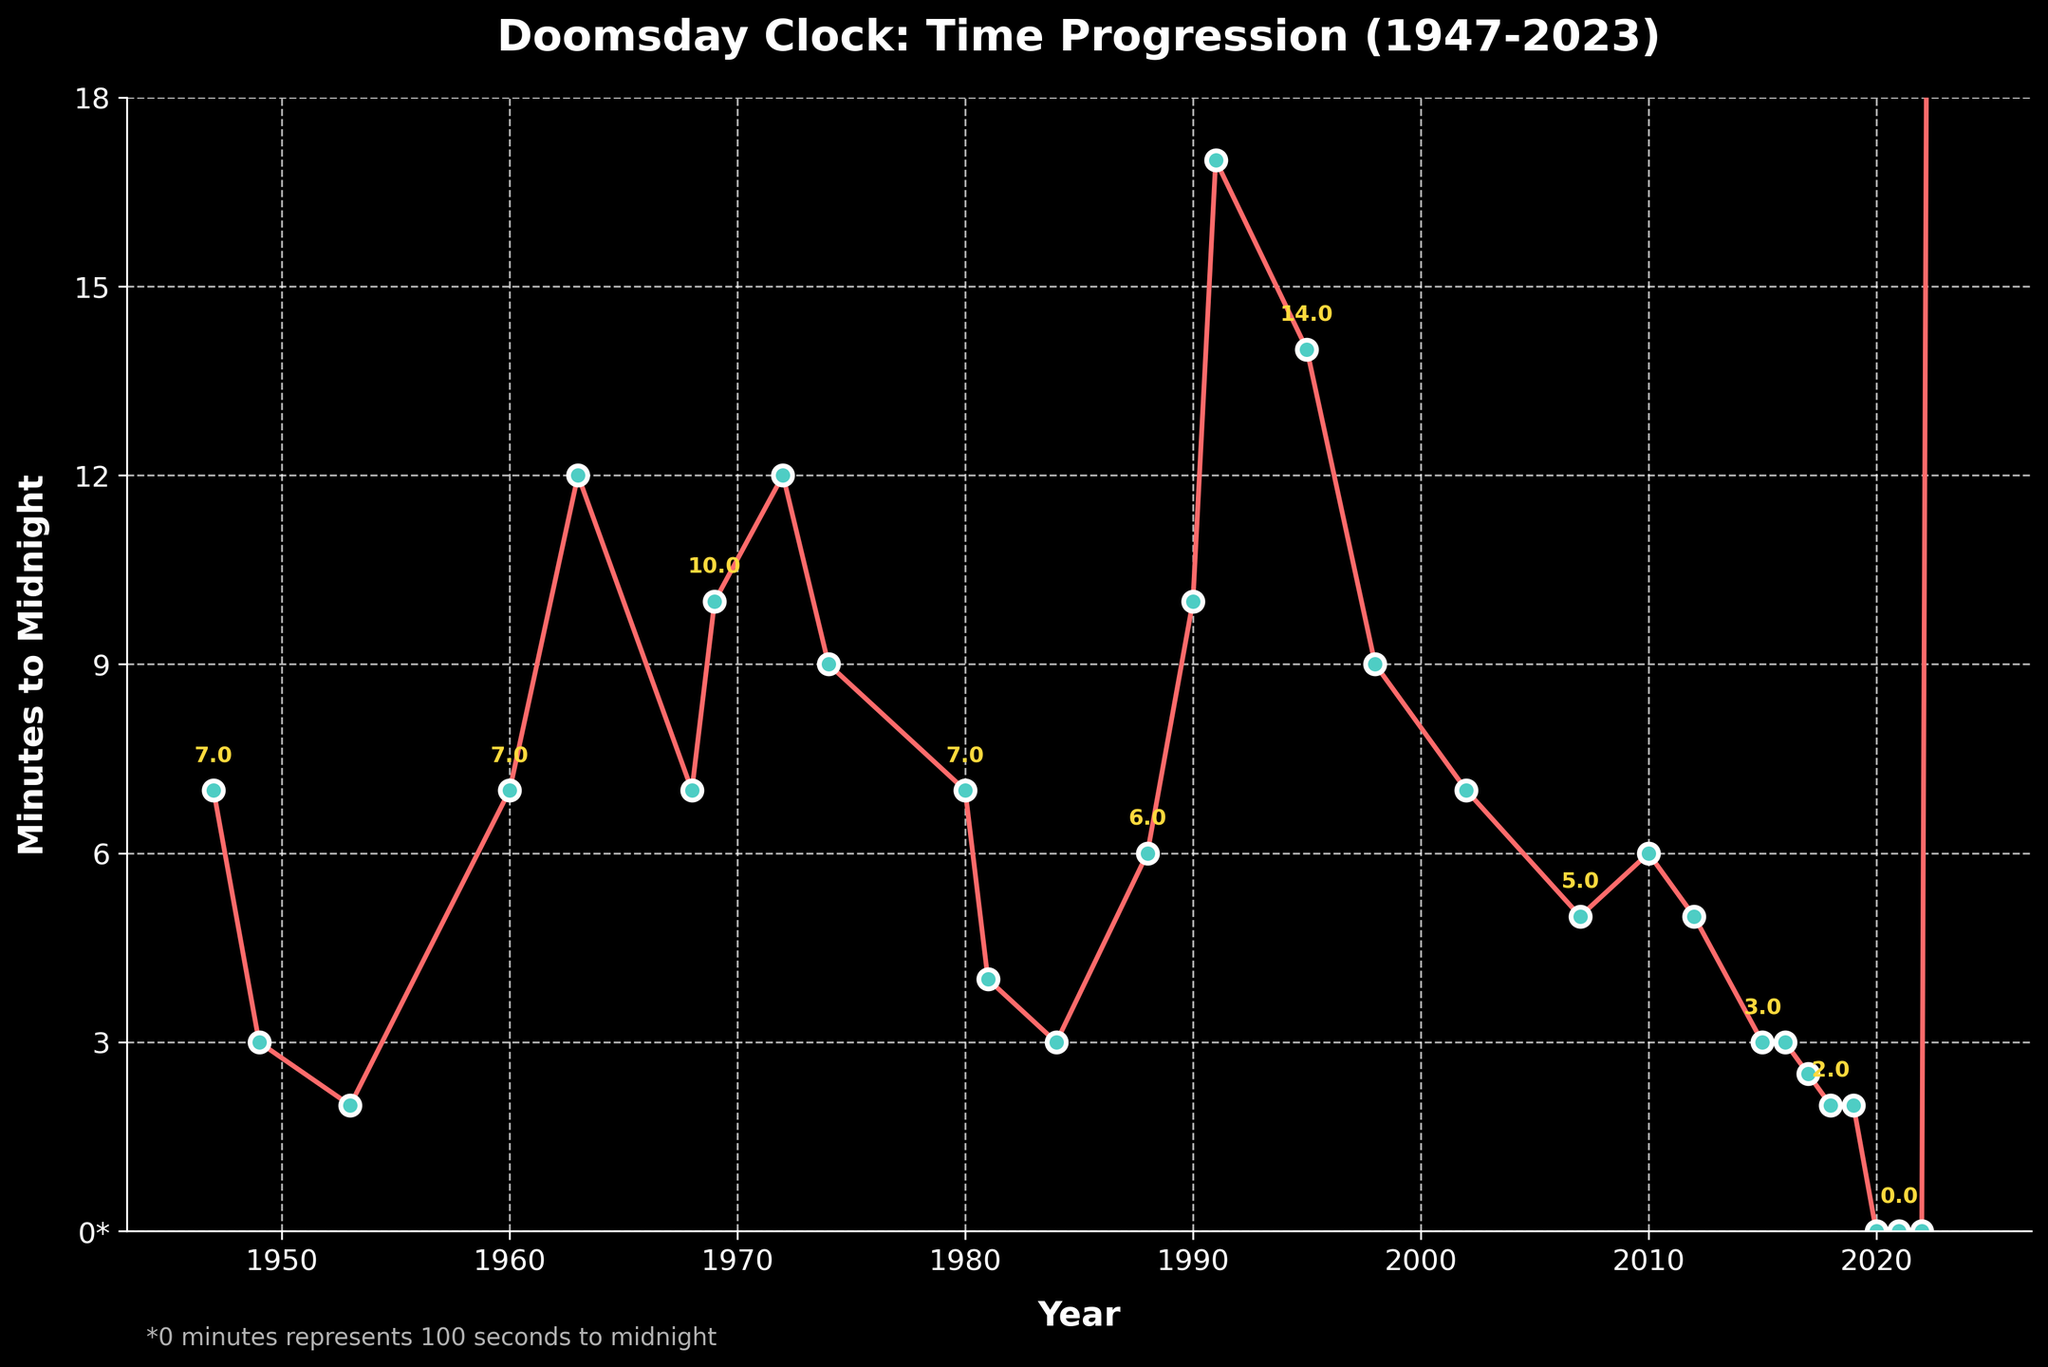What is the closest the Doomsday Clock has ever been to midnight? The closest time to midnight can be observed by identifying the smallest value on the y-axis. The smallest value shown is labeled as '2' and it occurs several times, such as in 1953 and 2018. This means the Doomsday Clock has been as close as 2 minutes to midnight.
Answer: 2 minutes How many times has the Doomsday Clock been set to exactly 7 minutes to midnight? By examining the y-axis values at intersections with the line chart, we identify the years where the y-value is 7. These years are 1947, 1960, 1980, and 2002. Therefore, the clock has been set to 7 minutes to midnight four times.
Answer: 4 times Which year experienced the largest increase in minutes to midnight in the period covered by the chart? To find the largest increase, we need to check the difference between consecutive data points. The largest jump is from 1991 (17) to 1995 (14), which is an increase of 3 minutes. Therefore, the largest increase appears visually to be in that period.
Answer: 1991 What's the longest period during which the Doomsday Clock stayed below 3 minutes to midnight? Identify periods where the value on the y-axis is consistently below 3. From 2017 to 2019, the values are 2.5, 2, and 2. Therefore, 2017 to 2019 is the longest period with the clock below 3 minutes.
Answer: 3 years In which year did the Doomsday Clock show the furthest time from midnight? The value furthest from midnight is the highest value on the y-axis. From the chart, the highest point is 17 minutes in 1991. This represents the furthest time from midnight.
Answer: 1991 What pattern do you observe in the movement of the Doomsday Clock between 1974 and 1991? Examining the chart, between 1974 and 1991, the Clock initially shows minutes above 7, reaching as high as 12 in 1972, and then decreases to the low point of 3 before increasing steadily. This indicates periods of tension followed by periods of reduced tension during this time span.
Answer: Periods of tension and reduction Which years show the annotation '0*' and why is this significant? From the plot annotations, the years 2020, 2021, and 2022 display '0*' which represents 100 seconds to midnight. This annotation is significant as it implies the closest time to midnight ever recorded on the Doomsday Clock, indicating extreme global danger.
Answer: 2020, 2021, 2022 